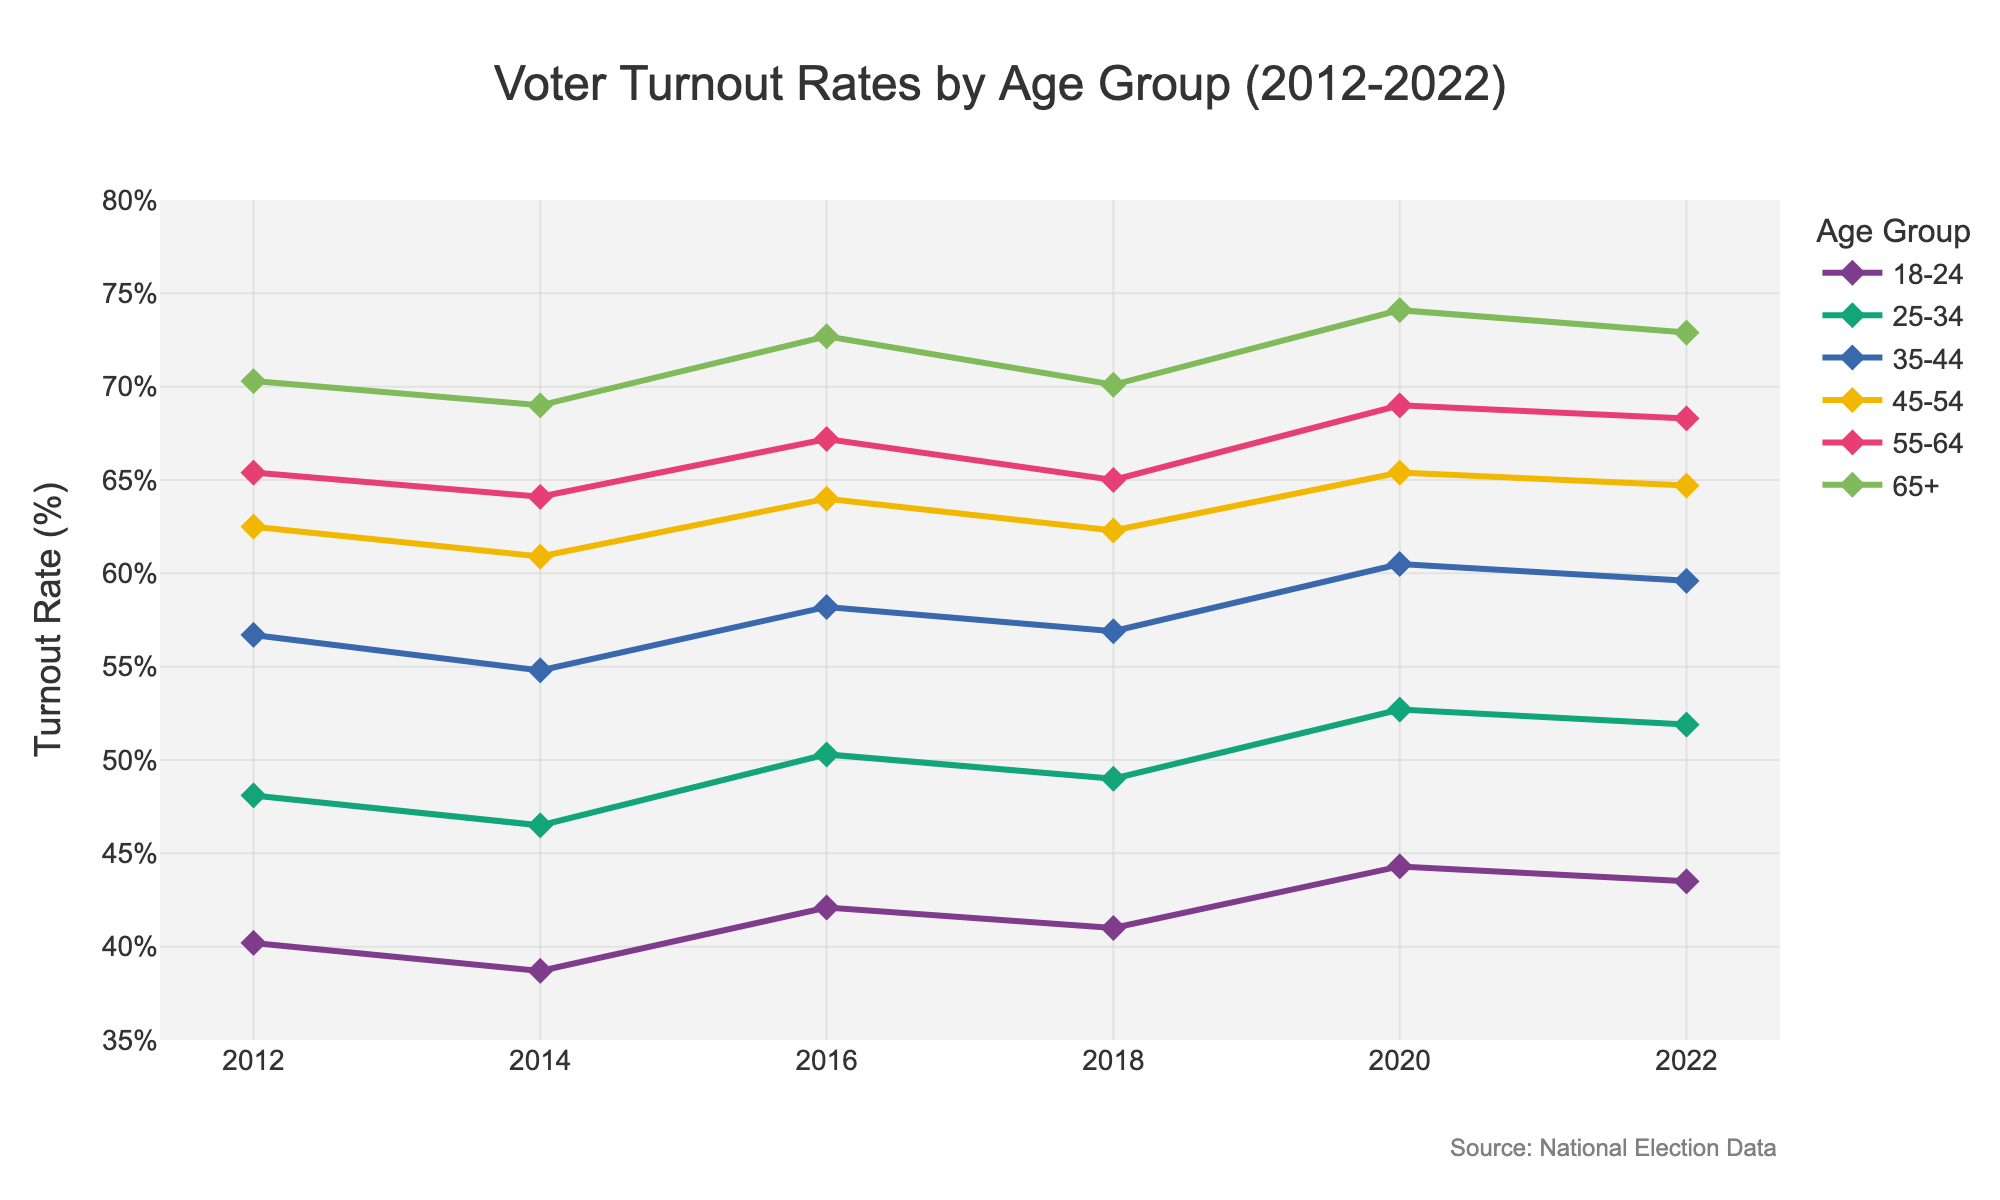What is the title of the plot? The title is displayed at the top of the plot. It reads "Voter Turnout Rates by Age Group (2012-2022)"
Answer: "Voter Turnout Rates by Age Group (2012-2022)" What is the turnout rate for the 18-24 age group in 2016? Locate the 18-24 age group line and find the data point corresponding to the year 2016. The turnout rate is 42.1%.
Answer: 42.1% Which age group had the highest turnout rate in 2020? Find the 2020 data points for all age groups and identify the group with the highest turnout rate, which is the 65+ age group at 74.1%.
Answer: 65+ Did the turnout rate for the 35-44 age group increase or decrease between 2014 and 2016? Compare the turnout rates for the 35-44 age group between 2014 (54.8%) and 2016 (58.2%). It increased.
Answer: Increased What is the overall trend in voter turnout for the 25-34 age group from 2012 to 2022? Observe the trend line for the 25-34 age group from 2012 to 2022. The turnout rate consistently increases from 48.1% in 2012 to 51.9% in 2022.
Answer: Increasing Compare the turnout rates between the 45-54 and 55-64 age groups in 2018. Which has a higher turnout? Locate the 2018 data points for the 45-54 (62.3%) and 55-64 (65%) age groups. The 55-64 age group has a higher turnout rate.
Answer: 55-64 By how much did the turnout rate for the 25-34 age group change from 2018 to 2020? Find the turnout rates for 25-34 in 2018 (49%) and 2020 (52.7%). The change is 52.7% - 49% = 3.7%.
Answer: 3.7% Which age group consistently had the lowest turnout rate across the years displayed? Observe the lines for each age group over time; the 18-24 age group consistently has the lowest turnout rates.
Answer: 18-24 What is the average turnout rate for the 65+ age group from 2012 to 2022? Calculate the average of the turnout rates for the 65+ age group across the given years: (70.3% + 69% + 72.7% + 70.1% + 74.1% + 72.9%) / 6 = 71.5%.
Answer: 71.5% What was the turnout rate for the 55-64 age group in the last year displayed? Locate the turnout rate for the 55-64 age group in 2022. It is 68.3%.
Answer: 68.3% 